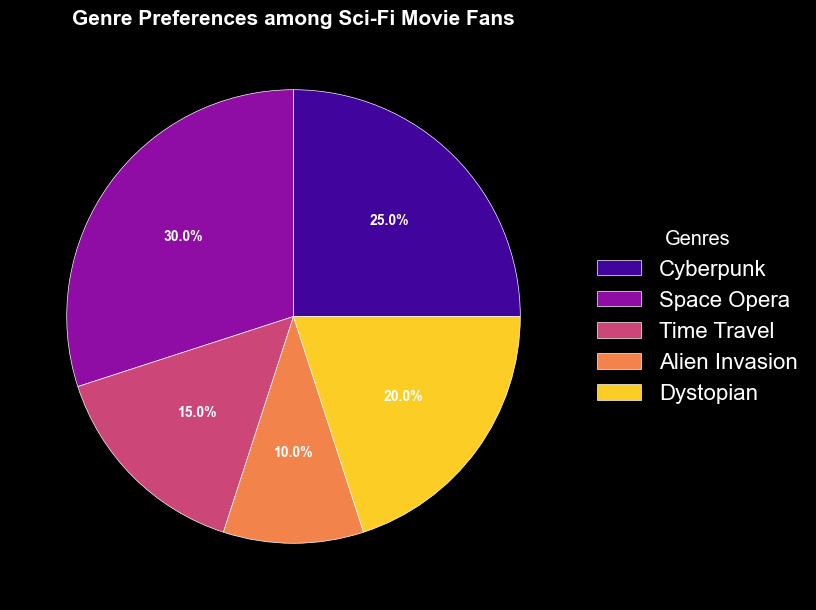what genre has the highest preference among sci-fi movie fans? The wedge labeled "Space Opera" is the largest slice in the pie chart, representing the highest preference percentage.
Answer: Space Opera what is the combined preference percentage for both Cyberpunk and Dystopian genres? Add the percentages for Cyberpunk (25%) and Dystopian (20%) together: 25 + 20 = 45.
Answer: 45% which genre has a lower preference: Alien Invasion or Time Travel? Compare the percentages for Alien Invasion (10%) and Time Travel (15%). Alien Invasion has a lower preference since 10 is less than 15.
Answer: Alien Invasion what percentage of sci-fi movie fans prefer genres other than Space Opera? The total percentage is 100%. Subtract the Space Opera percentage (30%) from 100: 100 - 30 = 70.
Answer: 70% how does the preference percentage for Cyberpunk compare to that of Alien Invasion? Cyberpunk (25%) is more preferred than Alien Invasion (10%) because 25 is greater than 10.
Answer: More preferred which genres combined represent exactly half of the preference percentage? Add the percentages for Cyberpunk (25%) and Space Opera (30%): 25 + 30 = 55. Since this exceeds half, recompute with other combinations: Time Travel (15%) + Dystopian (20%) + Alien Invasion (10%) = 45%. Finally, Cyberpunk (25%) + Dystopian (20%) = 45%. As none of these sum to exactly 50, it seems none.
Answer: None among Cyberpunk, Space Opera, and Dystopian, which two genres have the smallest difference in preference percentage? Compute the differences: Cyberpunk (25%) - Dystopian (20%) = 5%, Cyberpunk (25%) - Space Opera (30%) = 5%, Space Opera (30%) - Dystopian (20%) = 10%. The smallest differences are between Cyberpunk and both the Dystopian and Space Opera genres, both differences being the same.
Answer: Cyberpunk and Dystopian / Cyberpunk and Space Opera 